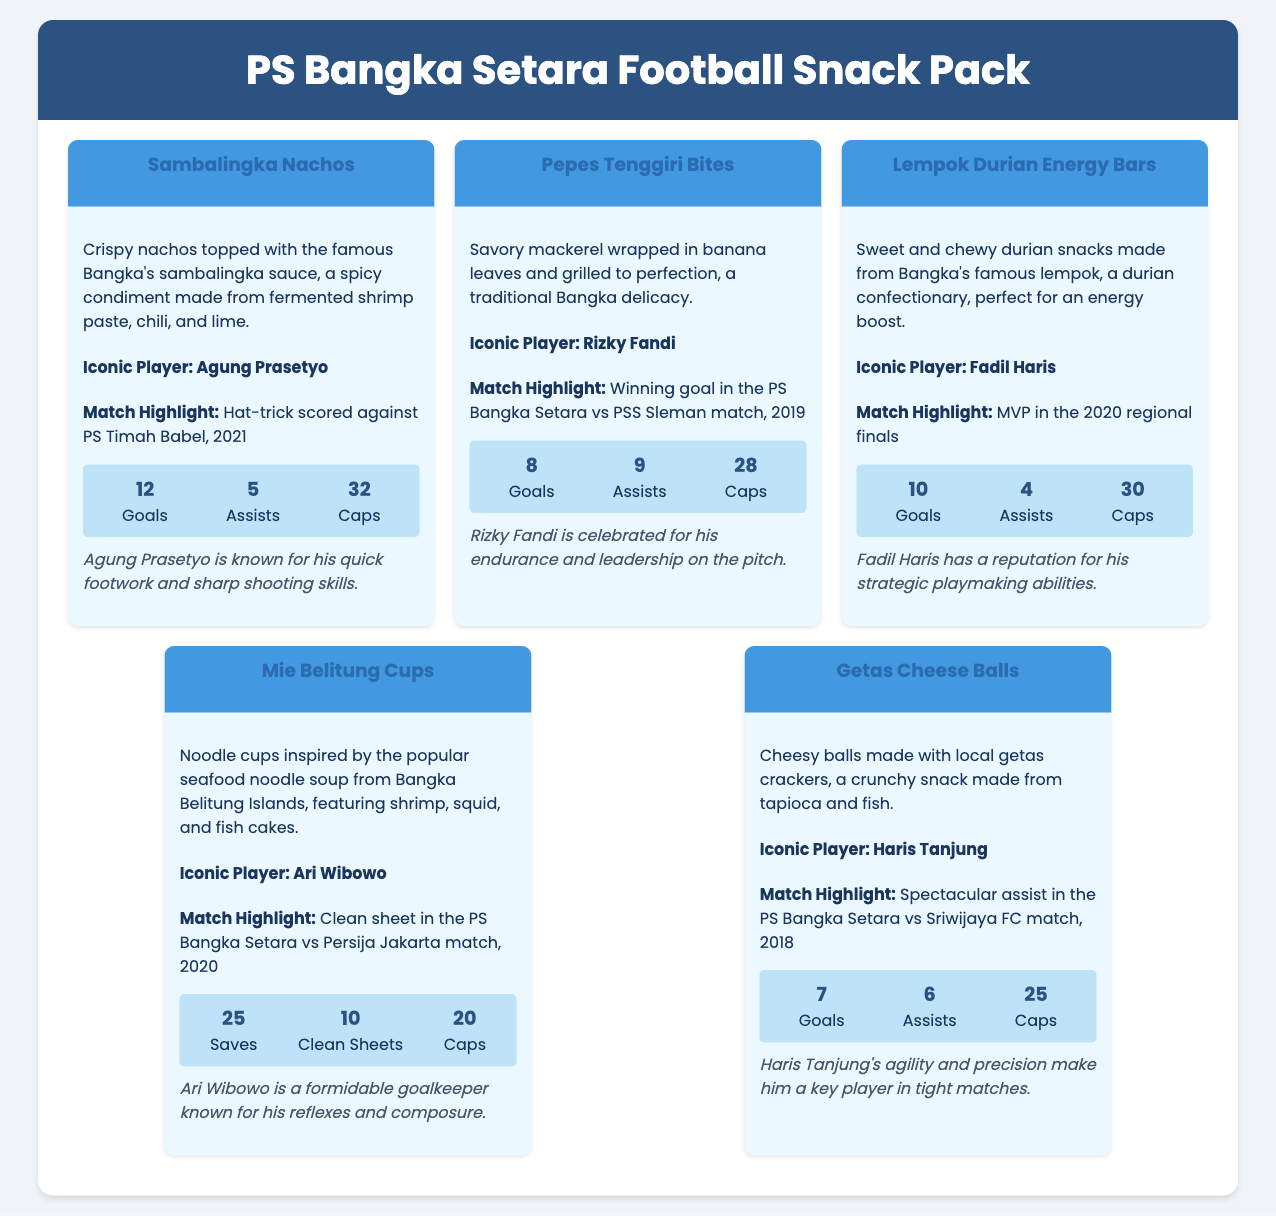What is the name of the first snack? The name of the first snack is located at the top of the first snack section.
Answer: Sambalingka Nachos Who is the iconic player associated with Pepes Tenggiri Bites? The iconic player for each snack is featured in the snack's content, specifically under the "Iconic Player" heading.
Answer: Rizky Fandi What year did Agung Prasetyo score a hat-trick? The year of Agung Prasetyo's hat-trick is mentioned in the match highlight for Sambalingka Nachos.
Answer: 2021 How many goals did Fadil Haris score? The goals scored by each player is listed in their respective player stats.
Answer: 10 What is the highlight for Mie Belitung Cups? Each snack has a match highlight under the "Match Highlight" heading to provide key match info related to the iconic player.
Answer: Clean sheet in the PS Bangka Setara vs Persija Jakarta match, 2020 Which snack is associated with Haris Tanjung? Each player is associated with a specific snack mentioned in the header of that snack section.
Answer: Getas Cheese Balls How many assists did Rizky Fandi have? The number of assists for each player is summarized in their player stats section.
Answer: 9 What type of product is this document describing? The document describes a product designed around food snacks themed after a football team.
Answer: Football Snack Pack What is the background color of the header? The header's background color can be observed at the top of the rendered document.
Answer: #2C5282 